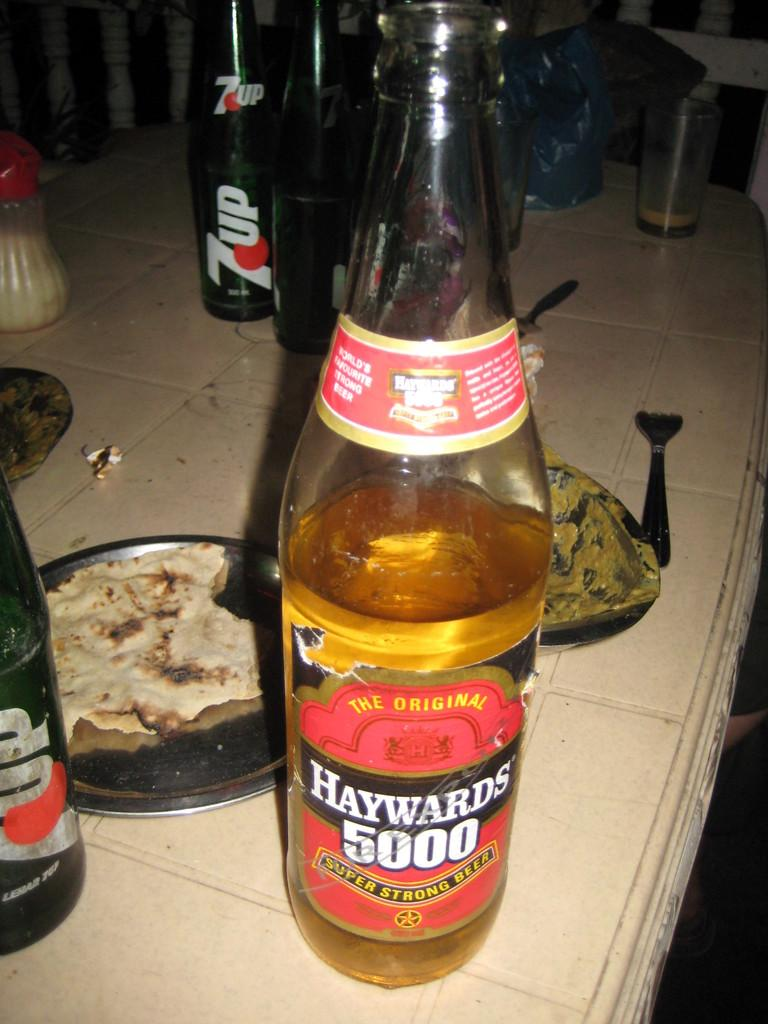<image>
Create a compact narrative representing the image presented. A dinner table with a bottle of Haywards 5000. 